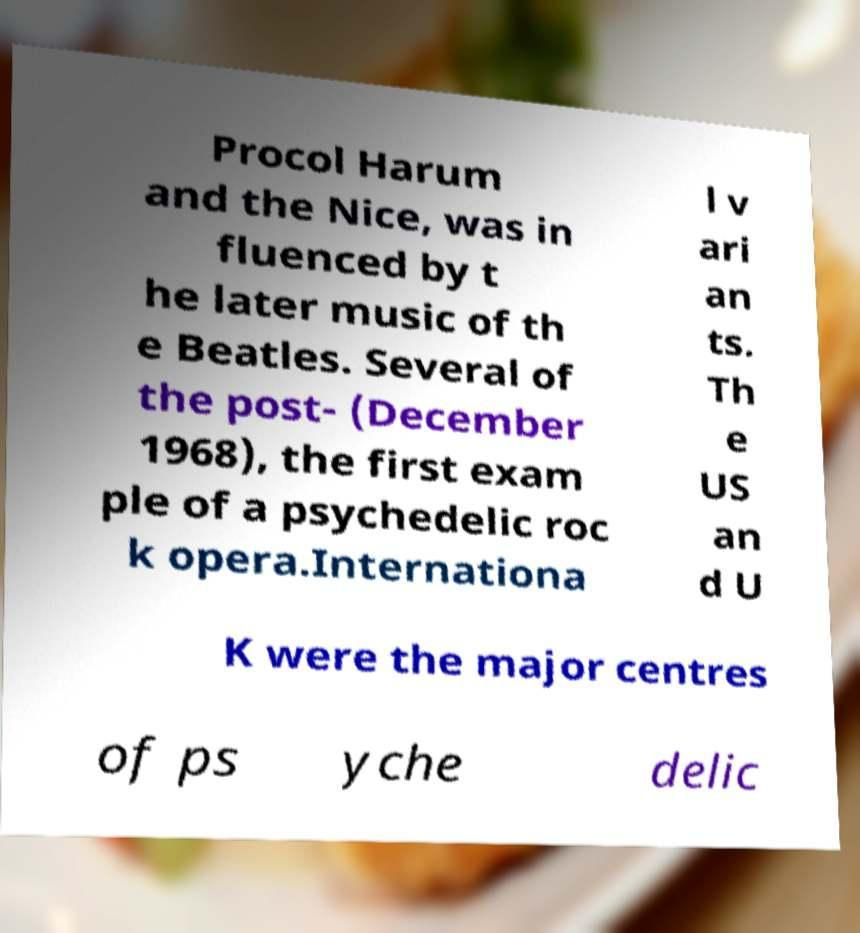Could you assist in decoding the text presented in this image and type it out clearly? Procol Harum and the Nice, was in fluenced by t he later music of th e Beatles. Several of the post- (December 1968), the first exam ple of a psychedelic roc k opera.Internationa l v ari an ts. Th e US an d U K were the major centres of ps yche delic 